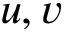<formula> <loc_0><loc_0><loc_500><loc_500>u , v</formula> 